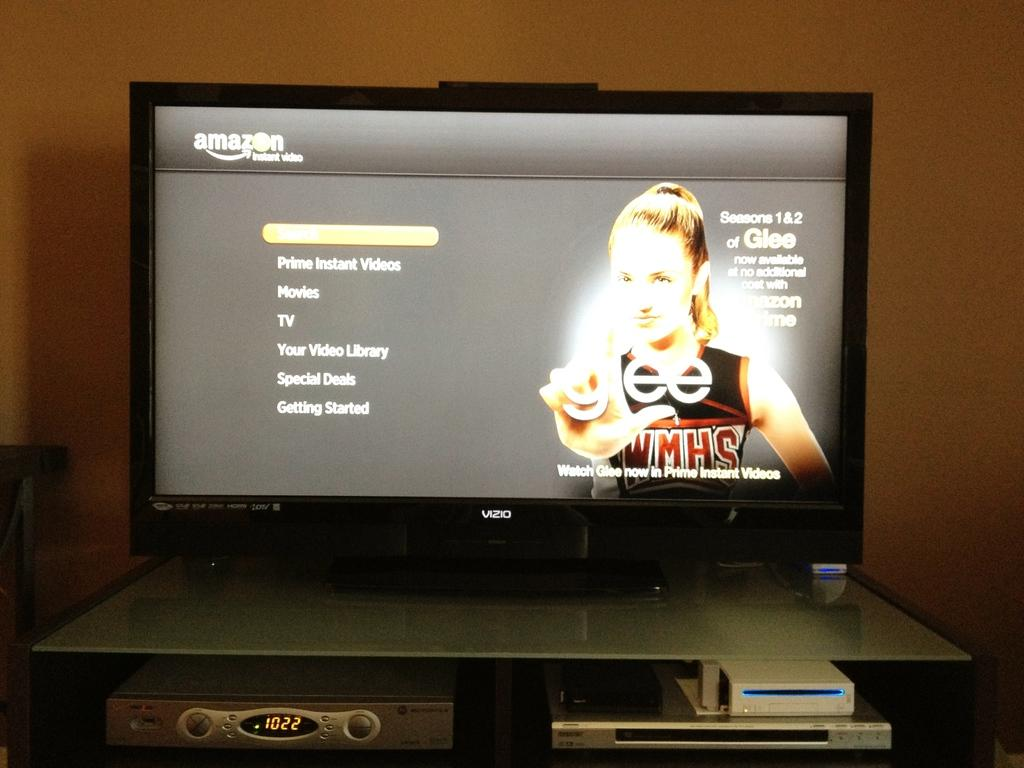<image>
Create a compact narrative representing the image presented. An Amazon prime menu that advertises the sitcom "Glee". 